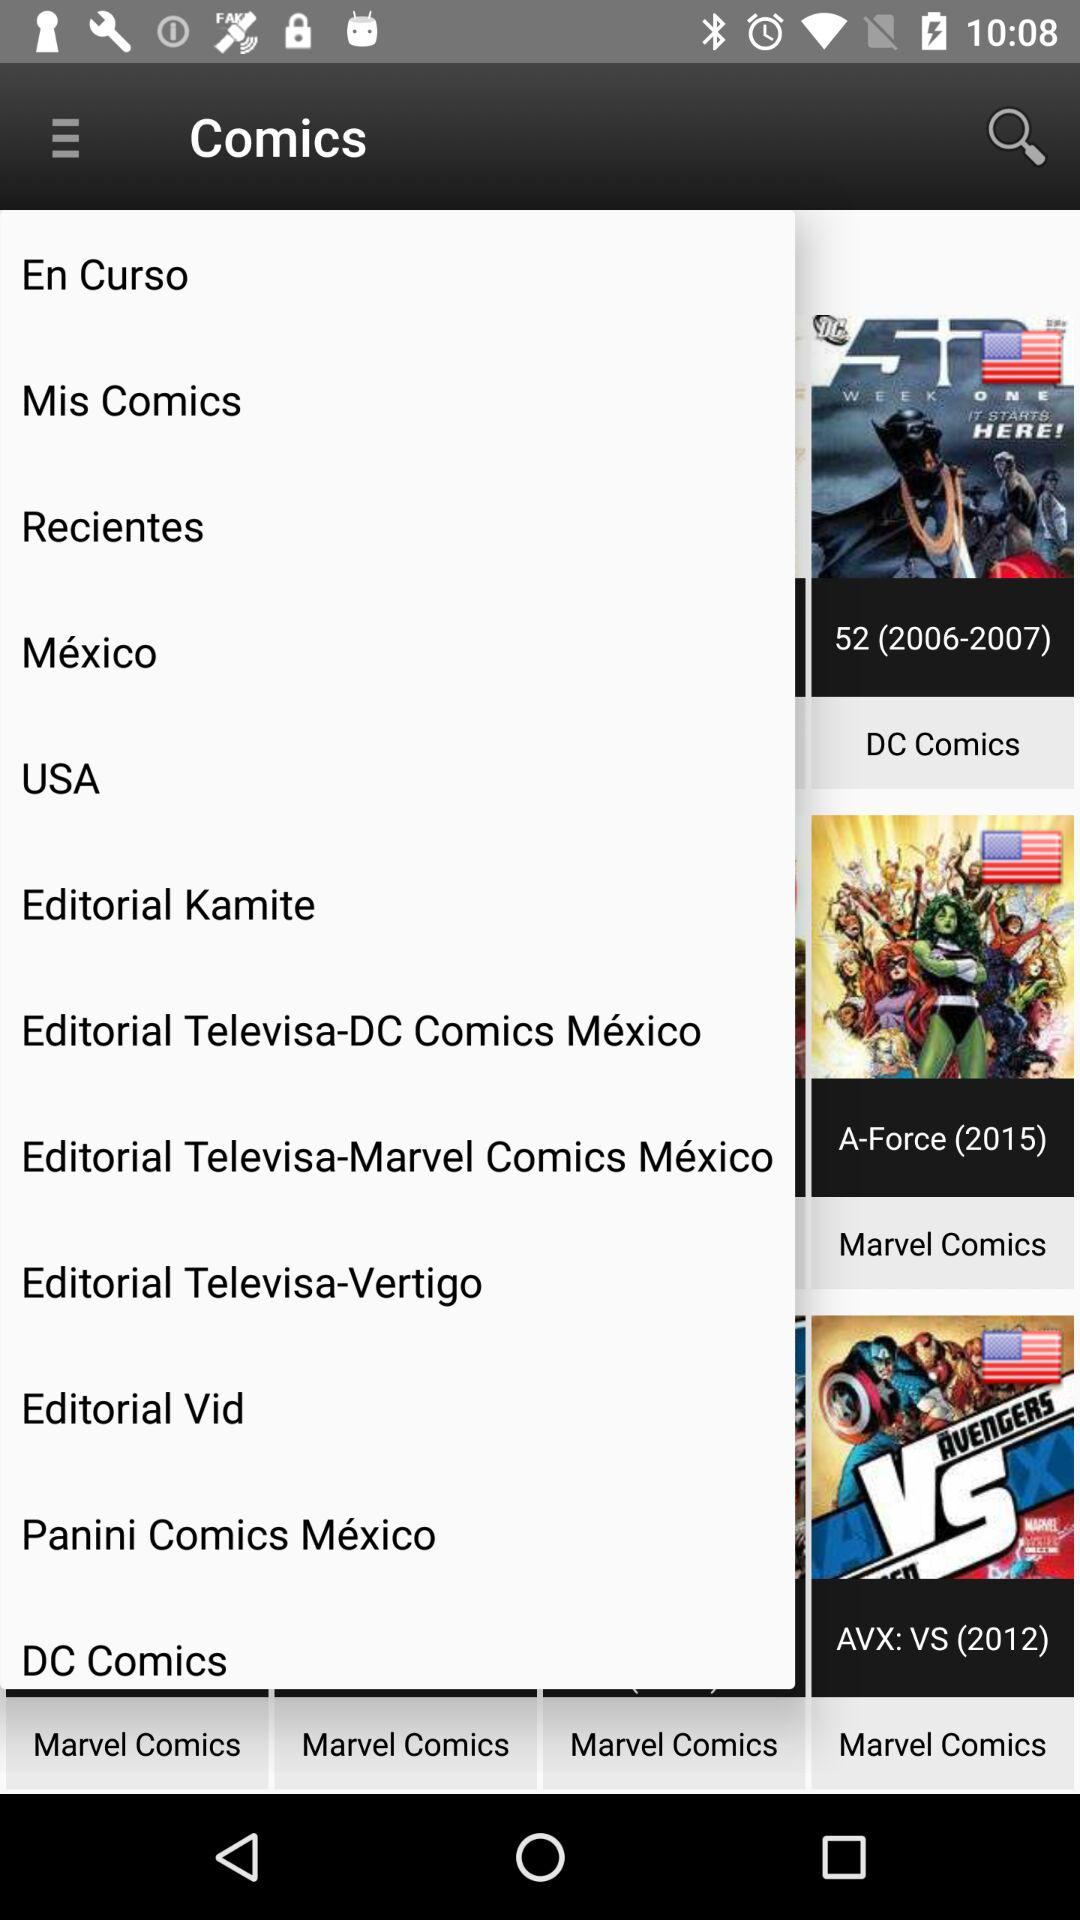What is the app name? The app name is "Comics". 